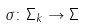<formula> <loc_0><loc_0><loc_500><loc_500>\sigma \colon \Sigma _ { k } \rightarrow \Sigma</formula> 